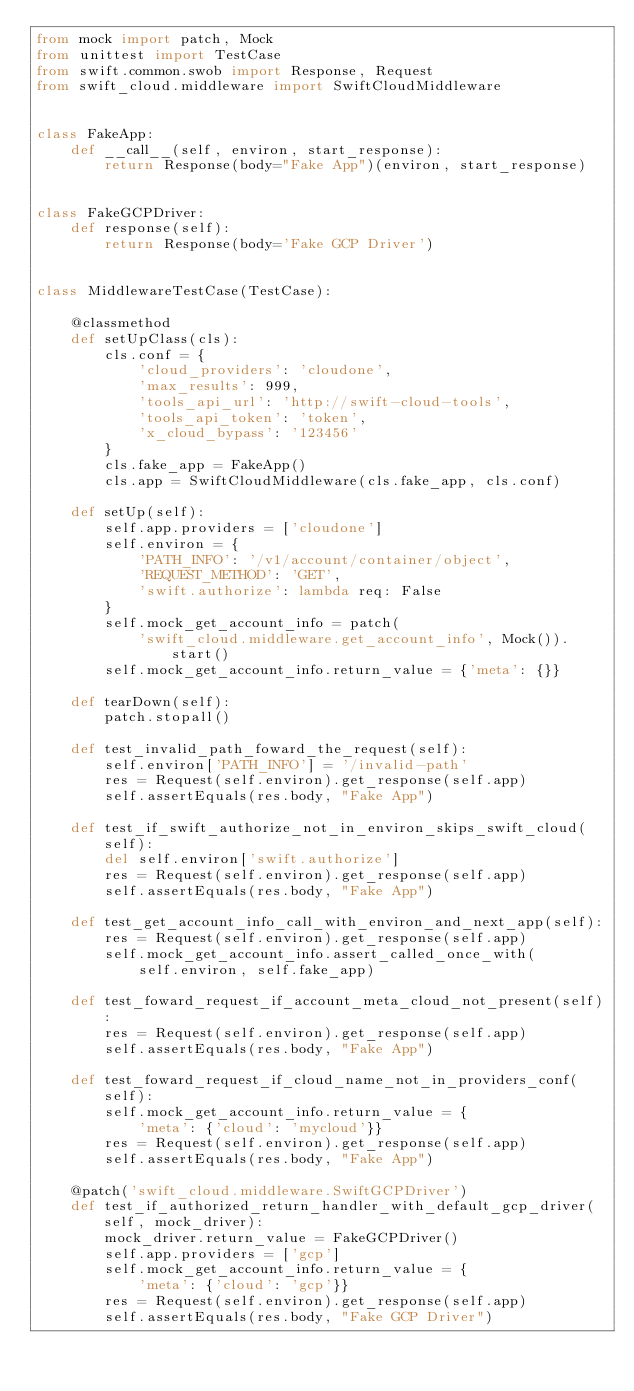<code> <loc_0><loc_0><loc_500><loc_500><_Python_>from mock import patch, Mock
from unittest import TestCase
from swift.common.swob import Response, Request
from swift_cloud.middleware import SwiftCloudMiddleware


class FakeApp:
    def __call__(self, environ, start_response):
        return Response(body="Fake App")(environ, start_response)


class FakeGCPDriver:
    def response(self):
        return Response(body='Fake GCP Driver')


class MiddlewareTestCase(TestCase):

    @classmethod
    def setUpClass(cls):
        cls.conf = {
            'cloud_providers': 'cloudone',
            'max_results': 999,
            'tools_api_url': 'http://swift-cloud-tools',
            'tools_api_token': 'token',
            'x_cloud_bypass': '123456'
        }
        cls.fake_app = FakeApp()
        cls.app = SwiftCloudMiddleware(cls.fake_app, cls.conf)

    def setUp(self):
        self.app.providers = ['cloudone']
        self.environ = {
            'PATH_INFO': '/v1/account/container/object',
            'REQUEST_METHOD': 'GET',
            'swift.authorize': lambda req: False
        }
        self.mock_get_account_info = patch(
            'swift_cloud.middleware.get_account_info', Mock()).start()
        self.mock_get_account_info.return_value = {'meta': {}}

    def tearDown(self):
        patch.stopall()

    def test_invalid_path_foward_the_request(self):
        self.environ['PATH_INFO'] = '/invalid-path'
        res = Request(self.environ).get_response(self.app)
        self.assertEquals(res.body, "Fake App")

    def test_if_swift_authorize_not_in_environ_skips_swift_cloud(self):
        del self.environ['swift.authorize']
        res = Request(self.environ).get_response(self.app)
        self.assertEquals(res.body, "Fake App")

    def test_get_account_info_call_with_environ_and_next_app(self):
        res = Request(self.environ).get_response(self.app)
        self.mock_get_account_info.assert_called_once_with(
            self.environ, self.fake_app)

    def test_foward_request_if_account_meta_cloud_not_present(self):
        res = Request(self.environ).get_response(self.app)
        self.assertEquals(res.body, "Fake App")

    def test_foward_request_if_cloud_name_not_in_providers_conf(self):
        self.mock_get_account_info.return_value = {
            'meta': {'cloud': 'mycloud'}}
        res = Request(self.environ).get_response(self.app)
        self.assertEquals(res.body, "Fake App")

    @patch('swift_cloud.middleware.SwiftGCPDriver')
    def test_if_authorized_return_handler_with_default_gcp_driver(self, mock_driver):
        mock_driver.return_value = FakeGCPDriver()
        self.app.providers = ['gcp']
        self.mock_get_account_info.return_value = {
            'meta': {'cloud': 'gcp'}}
        res = Request(self.environ).get_response(self.app)
        self.assertEquals(res.body, "Fake GCP Driver")
</code> 